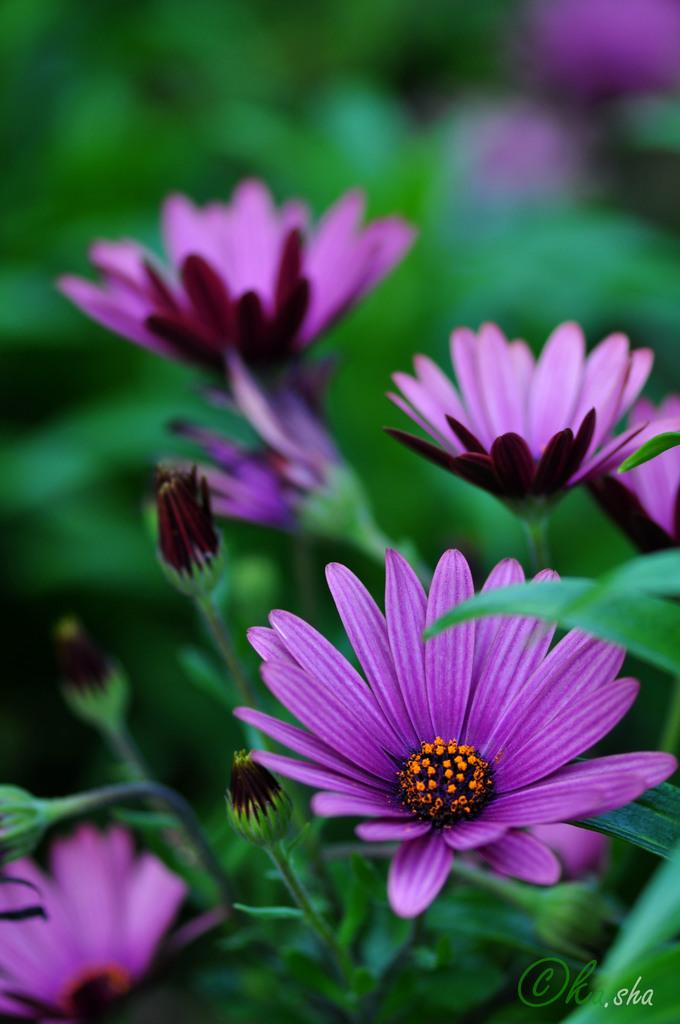What type of plant life is present in the image? There are flowers in the image. What color are the flowers? The flowers are purple. What else can be seen in the background of the image? There are leaves in the background of the image. What color are the leaves? The leaves are green. What grade did the flowers receive for their performance in the image? There is no grading system or performance evaluation for flowers in the image. 